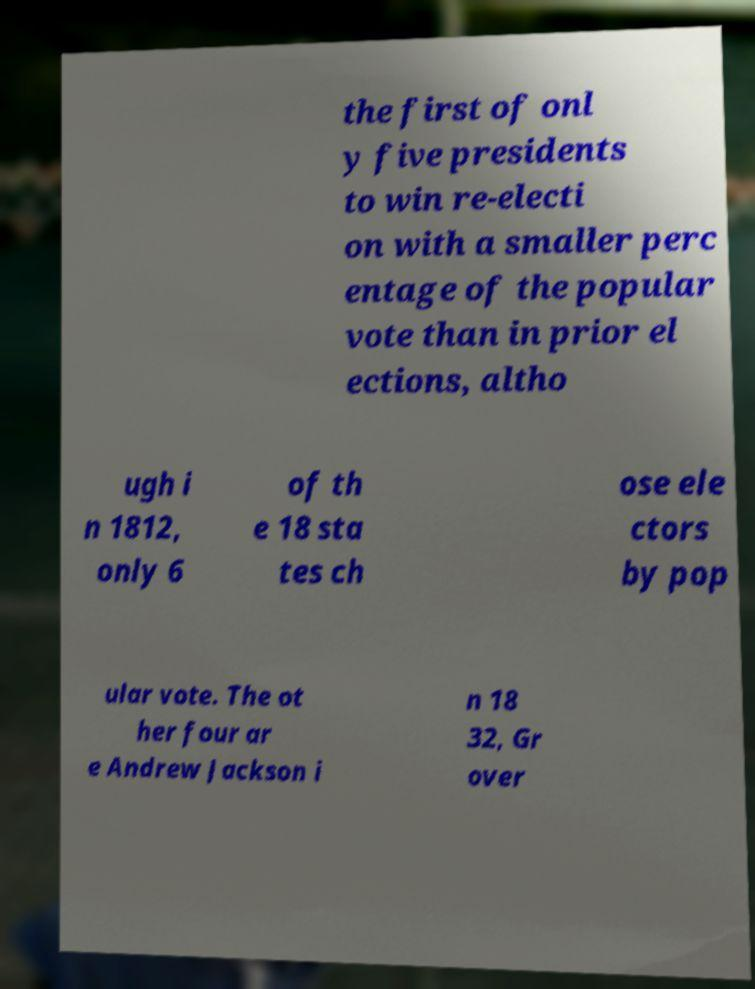Please read and relay the text visible in this image. What does it say? the first of onl y five presidents to win re-electi on with a smaller perc entage of the popular vote than in prior el ections, altho ugh i n 1812, only 6 of th e 18 sta tes ch ose ele ctors by pop ular vote. The ot her four ar e Andrew Jackson i n 18 32, Gr over 